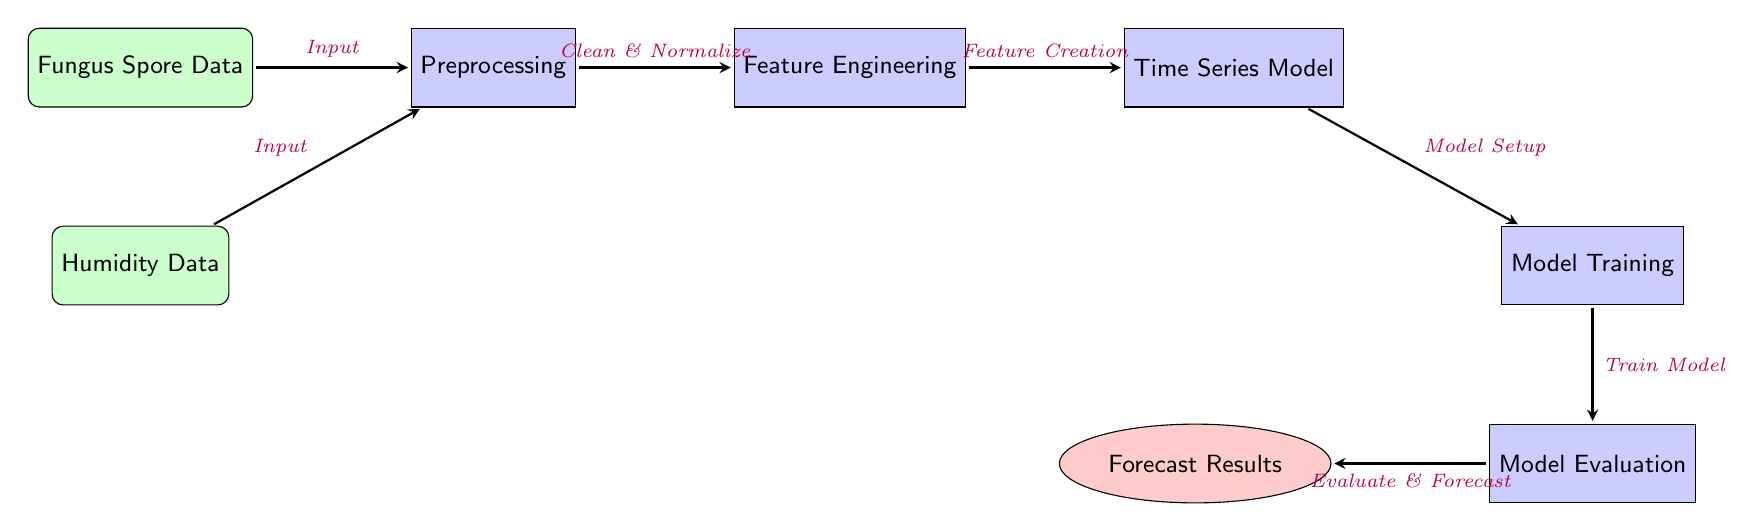What are the two types of input data in this diagram? The diagram shows two input nodes: "Fungus Spore Data" and "Humidity Data". This is a direct observation from the nodes labeled as inputs at the top of the diagram.
Answer: Fungus Spore Data, Humidity Data How many processes are indicated in the diagram? By counting the nodes categorized as processes, we have "Preprocessing", "Feature Engineering", "Time Series Model", "Model Training", and "Model Evaluation", totaling five process nodes.
Answer: Five What is the output of this diagram? The output node at the end of the diagram is labeled "Forecast Results", indicating what the system produces after completing the steps.
Answer: Forecast Results What step comes after "Preprocessing"? According to the flow of the diagram, after "Preprocessing", the next step is "Feature Engineering", as indicated by the arrow connecting the two process nodes.
Answer: Feature Engineering Which process is responsible for creating features? The arrow from "Feature Engineering" indicates that this process is labeled as "Feature Creation", signifying its role in the diagram.
Answer: Feature Creation What is the last process before obtaining forecast results? Examining the flow, the final process before reaching the output "Forecast Results" is "Model Evaluation", which directly precedes the output node.
Answer: Model Evaluation What action occurs after "Model Setup"? The diagram shows that immediately after "Model Setup", the process labeled "Model Training" occurs, indicating the sequence of operations designed for model preparation.
Answer: Model Training Which input data is directly connected to preprocessing? The diagram clearly shows both "Fungus Spore Data" and "Humidity Data" feeding into the "Preprocessing" node, but to answer specifically, "Humidity Data" is connected as well.
Answer: Humidity Data What is the purpose of the "Model Training" process? While the diagram does not explicitly define purposes, one can reason that from its label "Train Model", it is implied that this process's goal is to train the model using the features created previously.
Answer: Train Model 